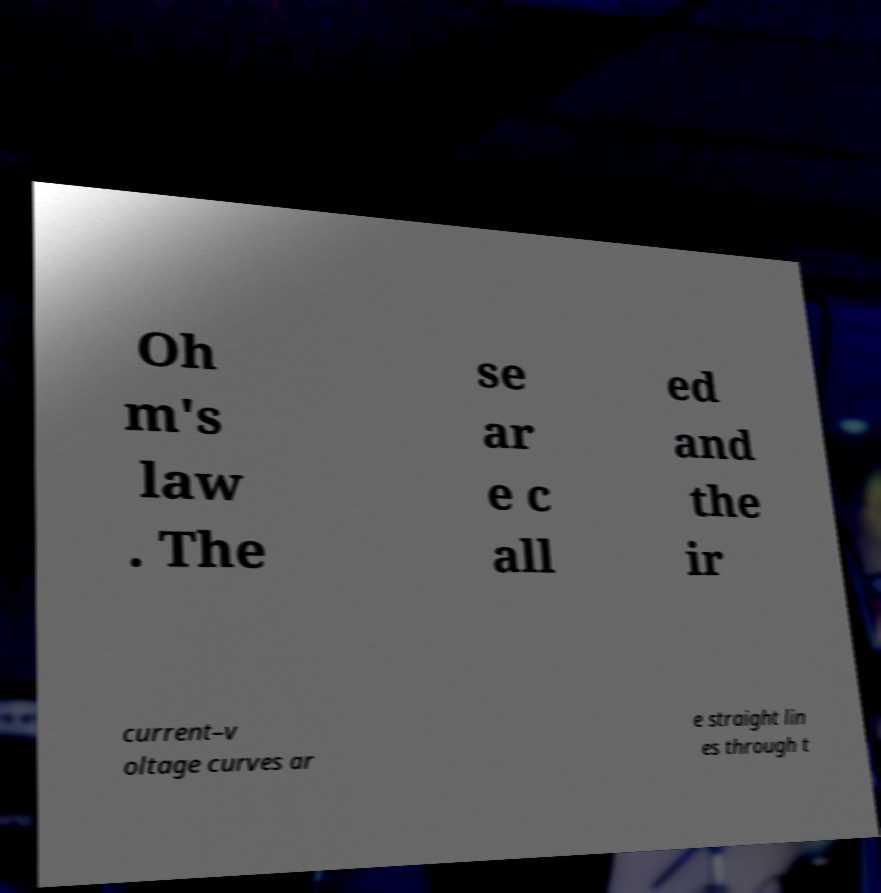What messages or text are displayed in this image? I need them in a readable, typed format. Oh m's law . The se ar e c all ed and the ir current–v oltage curves ar e straight lin es through t 